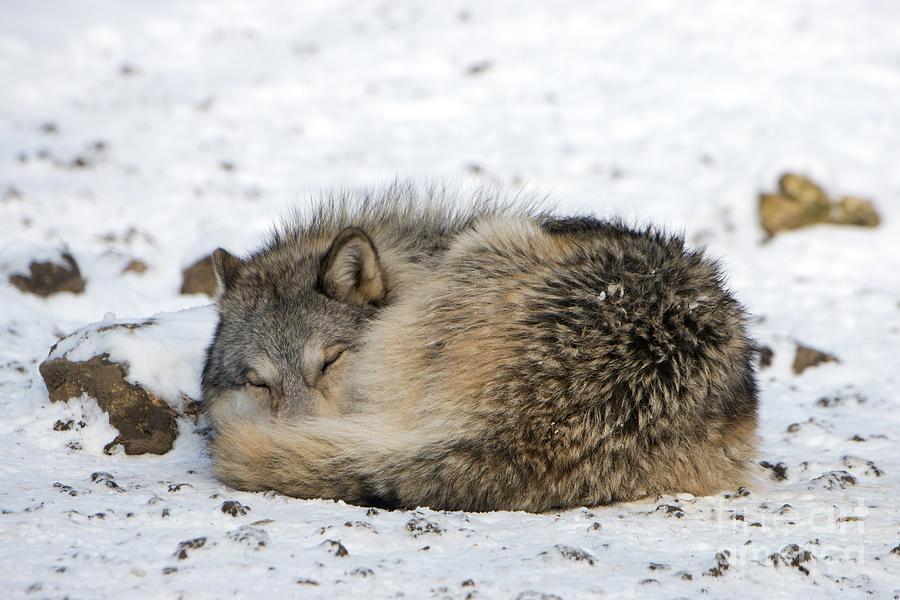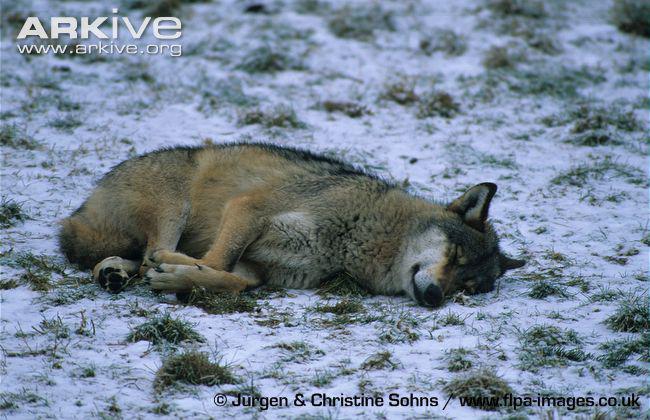The first image is the image on the left, the second image is the image on the right. For the images shown, is this caption "At least one wolf is sleeping in the snow." true? Answer yes or no. Yes. The first image is the image on the left, the second image is the image on the right. For the images shown, is this caption "One whitish wolf sleeps with its chin resting on its paws in one image." true? Answer yes or no. No. 